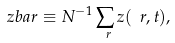<formula> <loc_0><loc_0><loc_500><loc_500>\ z b a r \equiv N ^ { - 1 } \sum _ { \ r } z ( \ r , t ) ,</formula> 